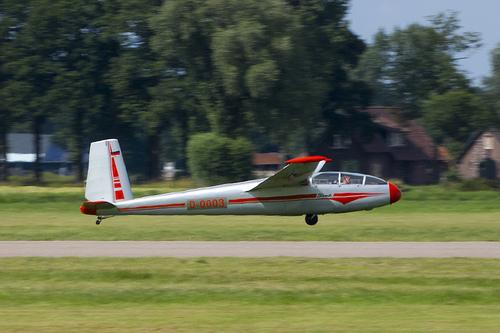In the multi-choice VQA task, select the right answer: What color is the grass next to the runway? a) brown, b) green, c) yellow b) green What color is the airplane and what is it preparing to do? The airplane is red and grey, and it is preparing to take off or land on the runway. Identify the main features of the landscape in the image. The landscape contains green grass surrounding a runway and trees in the background. There are also a large house and a small house nearby. For the visual entailment task, determine if the following statement is true: "There is a blue and yellow airplane on a runway surrounded by green grass." False, the airplane is red and grey, not blue and yellow. Create a product advertisement for the red and grey airplane, highlighting its unique features. Introducing the sleek and stylish Red and Grey Private Airplane, designed for luxury and personalized comfort. Featuring efficient runway landing capabilities, a remarkable d0003 insignia, and striking aesthetics, this airplane is perfect for the discerning traveler. In the multi-choice VQA task, choose the correct option: What is located beside the runway? a) a desert, b) a river, c) green grass c) green grass For the visual entailment task, assess the truth of the following statement: "The small house is located far away from the large house." False, the small house is next to the large house. 